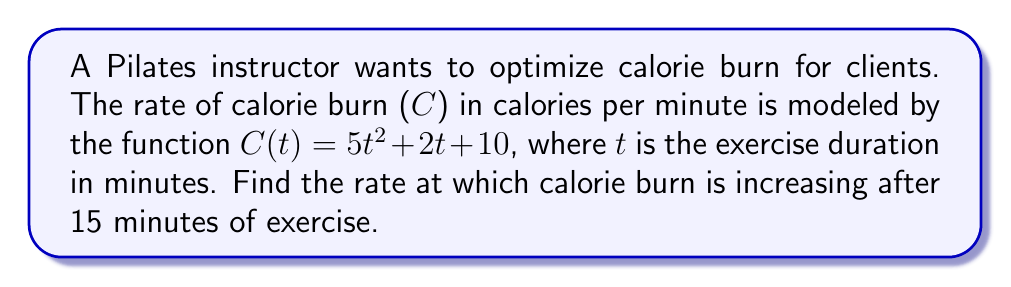Can you answer this question? To find the rate at which calorie burn is increasing after 15 minutes, we need to find the derivative of the function C(t) and evaluate it at t = 15.

Step 1: Find the derivative of C(t)
$$C(t) = 5t^2 + 2t + 10$$
$$C'(t) = \frac{d}{dt}(5t^2 + 2t + 10)$$
$$C'(t) = 10t + 2$$

Step 2: Evaluate C'(t) at t = 15
$$C'(15) = 10(15) + 2$$
$$C'(15) = 150 + 2 = 152$$

Therefore, after 15 minutes of exercise, the rate of calorie burn is increasing at 152 calories per minute per minute.
Answer: 152 calories/min² 